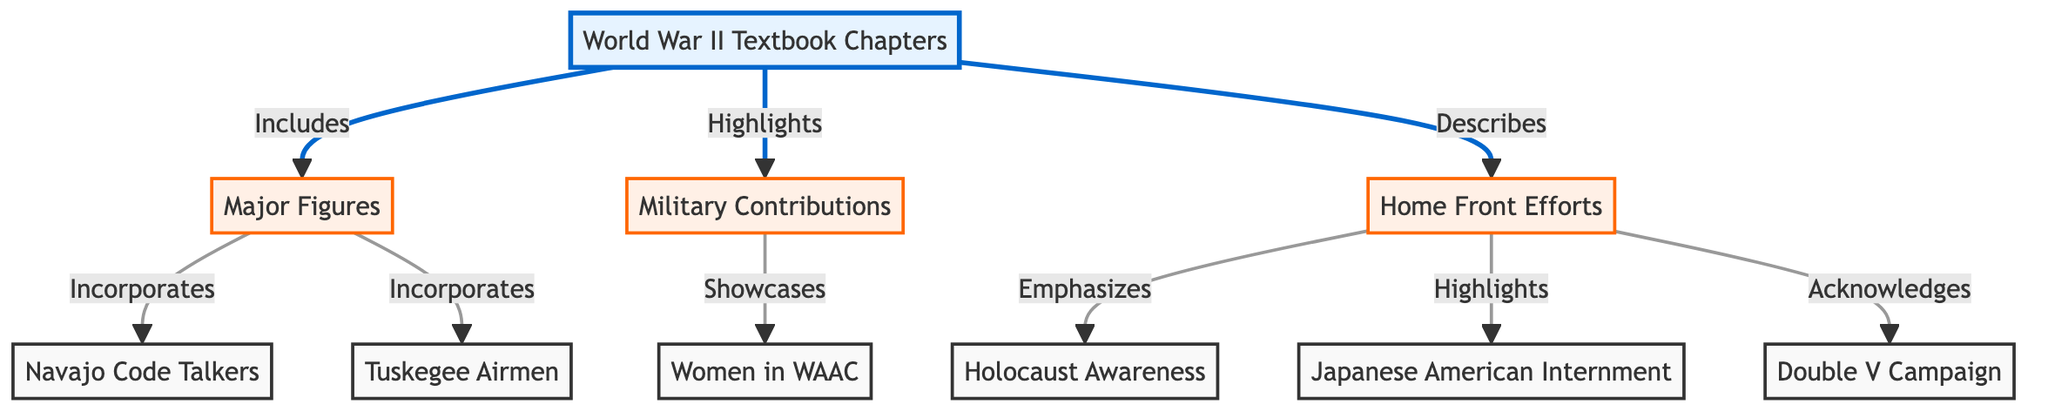What are the three main categories included in the World War II textbook chapters? The textbook chapters are divided into three main categories: Major Figures, Military Contributions, and Home Front Efforts. This can be seen branching directly from the textbook chapters node.
Answer: Major Figures, Military Contributions, Home Front Efforts Which specific figures are incorporated under Major Figures? Under the Major Figures category, the diagram specifies two individual contributions: Navajo Code Talkers and Tuskegee Airmen. Both of these are directly connected to the Major Figures node.
Answer: Navajo Code Talkers, Tuskegee Airmen How many contributions are highlighted in the Military Contributions category? The Military Contributions category specifically highlights one contribution, which is Women in WAAC. This can be seen as a direct connection from the Military Contributions node.
Answer: 1 What efforts are emphasized in the Home Front category? The Home Front category emphasizes three specific efforts: Holocaust Awareness, Japanese American Internment, and Double V Campaign. These are all distinctly shown as connections from the Home Front node.
Answer: Holocaust Awareness, Japanese American Internment, Double V Campaign Which specific campaign related to African American contributions is acknowledged in the diagram? The Double V Campaign specifically relates to African American contributions and is acknowledged under the Home Front category, which indicates its importance in discussing social justice issues during WWII.
Answer: Double V Campaign What kind of contributions does the Women in WAAC represent? The Women in WAAC represents military contributions as indicated by the direct connection from the Military Contributions node to Women in WAAC.
Answer: Military contributions How many nodes exist in total within the diagram? There are a total of eight nodes in the diagram, which includes the main textbook chapters node and its subcategories as well as individual contributions.
Answer: 8 Which chapter specifically acknowledges the Japanese American Internment? The Japanese American Internment is acknowledged under the Home Front category, reflecting its significance in the historical narrative of World War II.
Answer: Home Front Efforts 